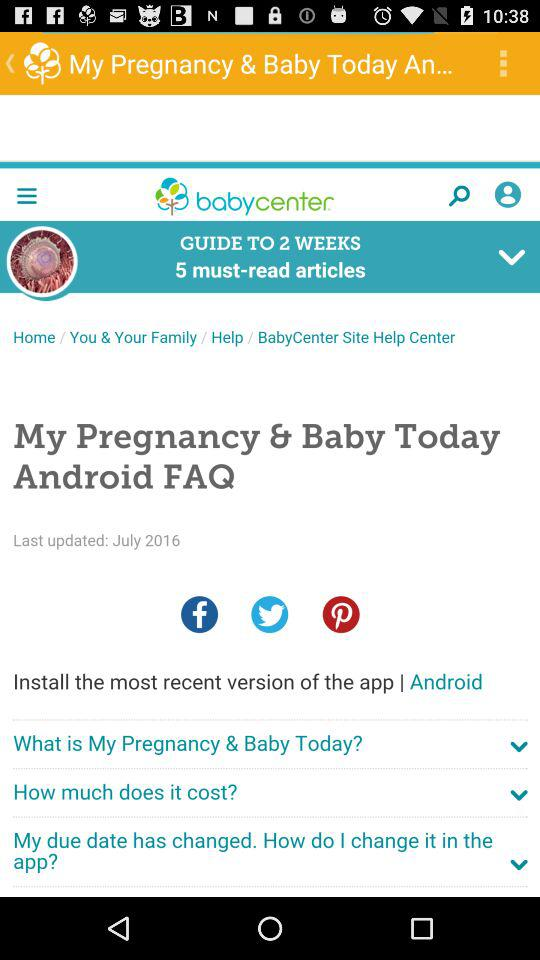What is the count of must-read articles? The count of must-read articles is 5. 